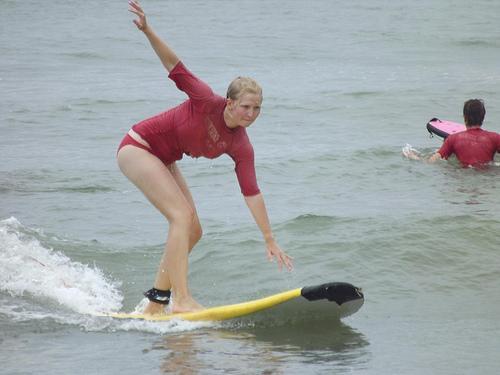How many people are in this picture?
Give a very brief answer. 2. 